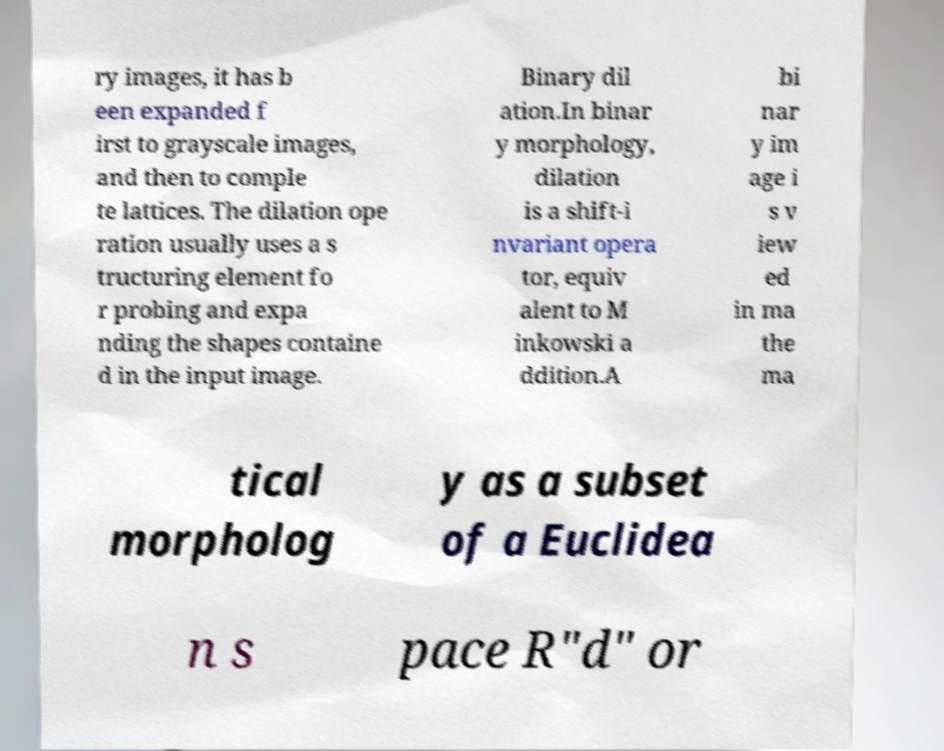Can you read and provide the text displayed in the image?This photo seems to have some interesting text. Can you extract and type it out for me? ry images, it has b een expanded f irst to grayscale images, and then to comple te lattices. The dilation ope ration usually uses a s tructuring element fo r probing and expa nding the shapes containe d in the input image. Binary dil ation.In binar y morphology, dilation is a shift-i nvariant opera tor, equiv alent to M inkowski a ddition.A bi nar y im age i s v iew ed in ma the ma tical morpholog y as a subset of a Euclidea n s pace R"d" or 